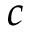Convert formula to latex. <formula><loc_0><loc_0><loc_500><loc_500>c</formula> 